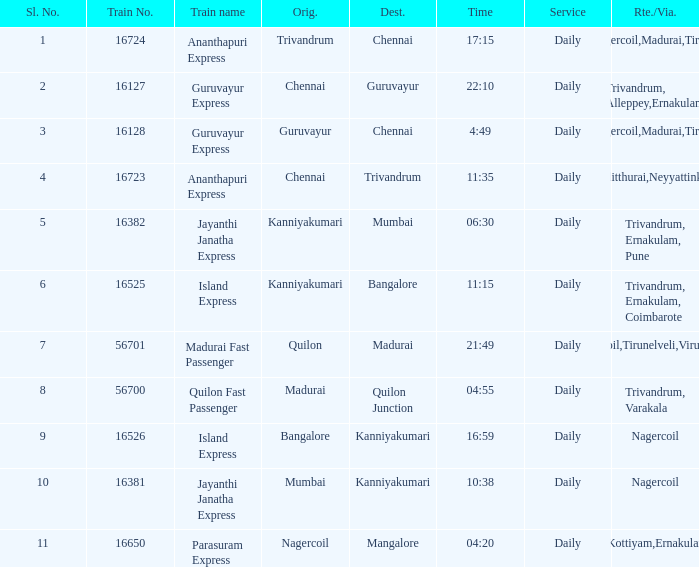What is the destination when the train number is 16526? Kanniyakumari. 